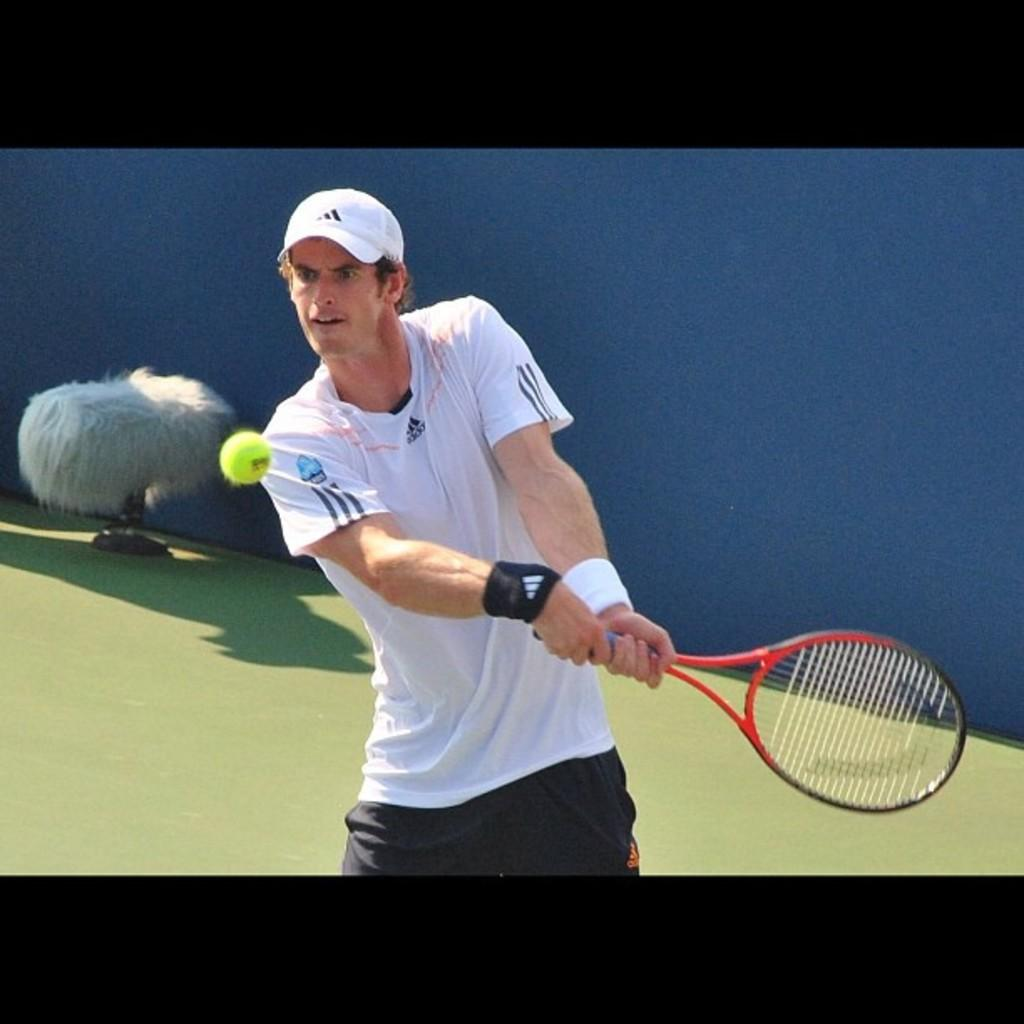Who is present in the image? There is a person in the image. What is the person holding in the image? The person is holding a tennis racket. What is happening with the tennis ball in the image? There is a tennis ball in the air. Can you describe the white object in the background of the image? There is a white object in the background of the image, but its specific nature cannot be determined from the provided facts. How many cats are visible in the image? There are no cats present in the image. What is the angle of the slope in the image? There is no slope present in the image. 